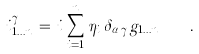<formula> <loc_0><loc_0><loc_500><loc_500>i ^ { \gamma } _ { 1 \dots n } \, = \, i \, \sum _ { i = 1 } ^ { n } \, \eta _ { i } \, \delta _ { \alpha _ { i } \gamma } g _ { 1 \dots n } \quad .</formula> 